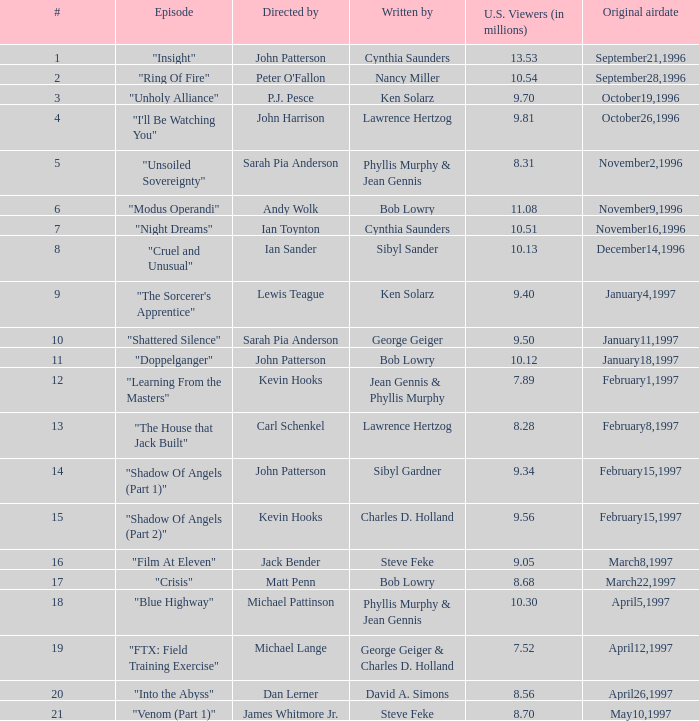What are the titles of episodes numbered 19? "FTX: Field Training Exercise". 